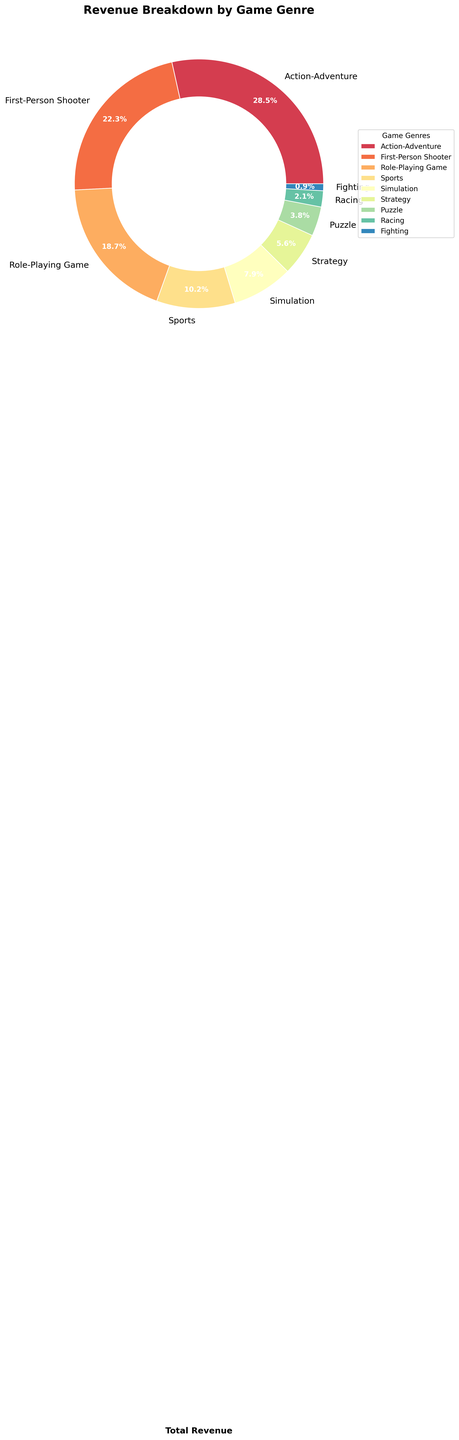Which game genre has the highest revenue percentage? By looking at the figure, the largest section of the pie chart corresponds to the genre with the highest revenue percentage. In this case, the largest section is Action-Adventure.
Answer: Action-Adventure Which genre contributes more revenue: Role-Playing Game or Sports? To find out which genre contributes more revenue, compare their respective positions in the pie chart. The Role-Playing Game section is larger than the Sports section.
Answer: Role-Playing Game What's the difference in revenue percentage between the First-Person Shooter and Simulation genres? To find the difference, identify the respective revenue percentages from the chart (First-Person Shooter: 22.3%, Simulation: 7.9%), and subtract the smaller percentage from the larger (22.3% - 7.9%).
Answer: 14.4% How much more revenue does the Strategy genre generate compared to the Puzzle genre? Determine the revenue percentages for Strategy (5.6%) and Puzzle (3.8%), then subtract the smaller one from the larger one (5.6% - 3.8%).
Answer: 1.8% What is the combined revenue percentage of the Sports and Simulation genres? Add the revenue percentages of the Sports (10.2%) and Simulation (7.9%) genres together (10.2% + 7.9%).
Answer: 18.1% Is the revenue percentage of Racing greater than or less than Strategy? Compare the sections for Racing (2.1%) and Strategy (5.6%) in the pie chart. Racing is smaller.
Answer: Less than Which genre has nearly 1% revenue share? Look for the genre close to 1% in the pie chart, which is Fighting (0.9%).
Answer: Fighting How many genres have a revenue share greater than 20%? Identify the sections in the pie chart with percentages greater than 20%, which are Action-Adventure and First-Person Shooter.
Answer: 2 Are there more genres with revenue percentages above or below 10%? Count genres with revenue percentages above 10% (3 genres) and below 10% (6 genres), comparing the counts.
Answer: Below What's the average revenue percentage of Role-Playing Game, Sports, Simulation, and Strategy genres? Add the percentages: Role-Playing Game (18.7%), Sports (10.2%), Simulation (7.9%), and Strategy (5.6%), then divide by the number of genres (4). (18.7 + 10.2 + 7.9 + 5.6) / 4
Answer: 10.6% 